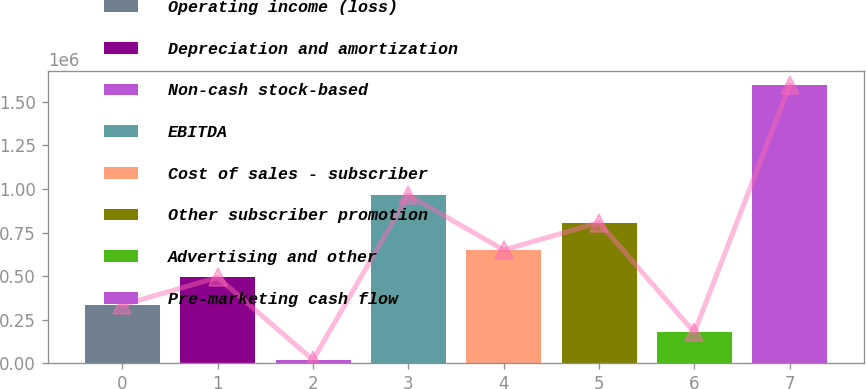Convert chart. <chart><loc_0><loc_0><loc_500><loc_500><bar_chart><fcel>Operating income (loss)<fcel>Depreciation and amortization<fcel>Non-cash stock-based<fcel>EBITDA<fcel>Cost of sales - subscriber<fcel>Other subscriber promotion<fcel>Advertising and other<fcel>Pre-marketing cash flow<nl><fcel>335239<fcel>492772<fcel>20173<fcel>965370<fcel>650305<fcel>807838<fcel>177706<fcel>1.5955e+06<nl></chart> 